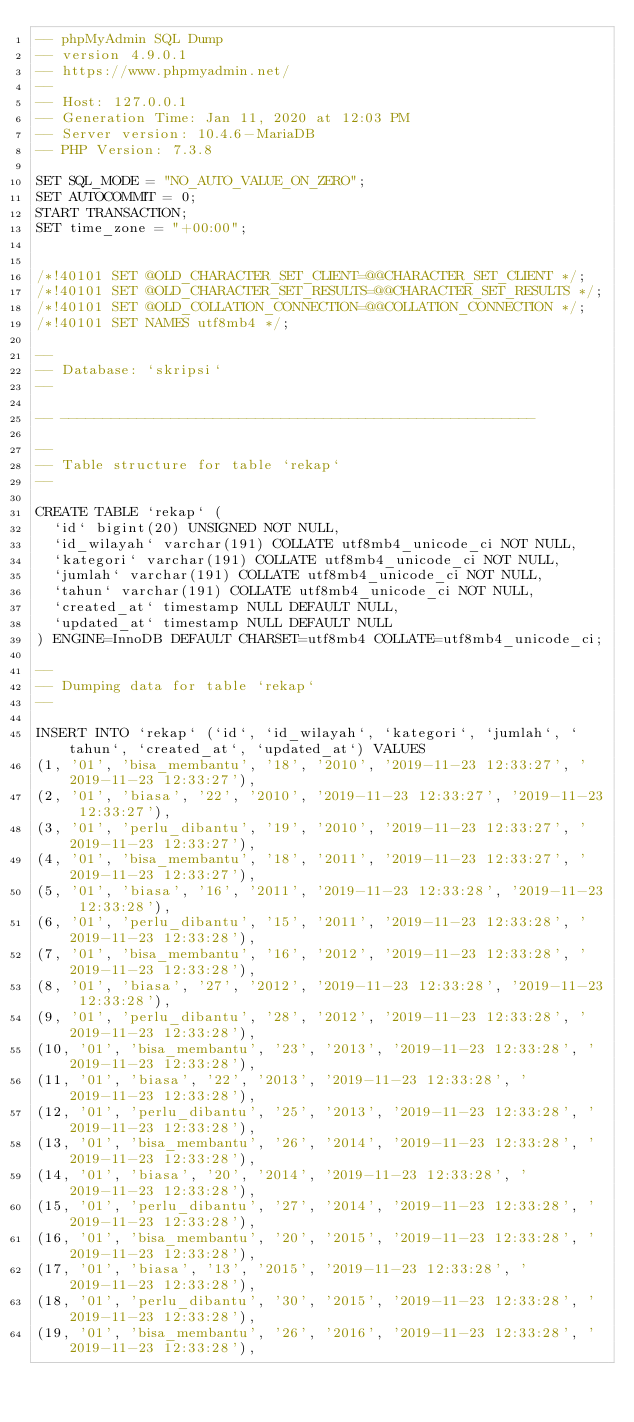Convert code to text. <code><loc_0><loc_0><loc_500><loc_500><_SQL_>-- phpMyAdmin SQL Dump
-- version 4.9.0.1
-- https://www.phpmyadmin.net/
--
-- Host: 127.0.0.1
-- Generation Time: Jan 11, 2020 at 12:03 PM
-- Server version: 10.4.6-MariaDB
-- PHP Version: 7.3.8

SET SQL_MODE = "NO_AUTO_VALUE_ON_ZERO";
SET AUTOCOMMIT = 0;
START TRANSACTION;
SET time_zone = "+00:00";


/*!40101 SET @OLD_CHARACTER_SET_CLIENT=@@CHARACTER_SET_CLIENT */;
/*!40101 SET @OLD_CHARACTER_SET_RESULTS=@@CHARACTER_SET_RESULTS */;
/*!40101 SET @OLD_COLLATION_CONNECTION=@@COLLATION_CONNECTION */;
/*!40101 SET NAMES utf8mb4 */;

--
-- Database: `skripsi`
--

-- --------------------------------------------------------

--
-- Table structure for table `rekap`
--

CREATE TABLE `rekap` (
  `id` bigint(20) UNSIGNED NOT NULL,
  `id_wilayah` varchar(191) COLLATE utf8mb4_unicode_ci NOT NULL,
  `kategori` varchar(191) COLLATE utf8mb4_unicode_ci NOT NULL,
  `jumlah` varchar(191) COLLATE utf8mb4_unicode_ci NOT NULL,
  `tahun` varchar(191) COLLATE utf8mb4_unicode_ci NOT NULL,
  `created_at` timestamp NULL DEFAULT NULL,
  `updated_at` timestamp NULL DEFAULT NULL
) ENGINE=InnoDB DEFAULT CHARSET=utf8mb4 COLLATE=utf8mb4_unicode_ci;

--
-- Dumping data for table `rekap`
--

INSERT INTO `rekap` (`id`, `id_wilayah`, `kategori`, `jumlah`, `tahun`, `created_at`, `updated_at`) VALUES
(1, '01', 'bisa_membantu', '18', '2010', '2019-11-23 12:33:27', '2019-11-23 12:33:27'),
(2, '01', 'biasa', '22', '2010', '2019-11-23 12:33:27', '2019-11-23 12:33:27'),
(3, '01', 'perlu_dibantu', '19', '2010', '2019-11-23 12:33:27', '2019-11-23 12:33:27'),
(4, '01', 'bisa_membantu', '18', '2011', '2019-11-23 12:33:27', '2019-11-23 12:33:27'),
(5, '01', 'biasa', '16', '2011', '2019-11-23 12:33:28', '2019-11-23 12:33:28'),
(6, '01', 'perlu_dibantu', '15', '2011', '2019-11-23 12:33:28', '2019-11-23 12:33:28'),
(7, '01', 'bisa_membantu', '16', '2012', '2019-11-23 12:33:28', '2019-11-23 12:33:28'),
(8, '01', 'biasa', '27', '2012', '2019-11-23 12:33:28', '2019-11-23 12:33:28'),
(9, '01', 'perlu_dibantu', '28', '2012', '2019-11-23 12:33:28', '2019-11-23 12:33:28'),
(10, '01', 'bisa_membantu', '23', '2013', '2019-11-23 12:33:28', '2019-11-23 12:33:28'),
(11, '01', 'biasa', '22', '2013', '2019-11-23 12:33:28', '2019-11-23 12:33:28'),
(12, '01', 'perlu_dibantu', '25', '2013', '2019-11-23 12:33:28', '2019-11-23 12:33:28'),
(13, '01', 'bisa_membantu', '26', '2014', '2019-11-23 12:33:28', '2019-11-23 12:33:28'),
(14, '01', 'biasa', '20', '2014', '2019-11-23 12:33:28', '2019-11-23 12:33:28'),
(15, '01', 'perlu_dibantu', '27', '2014', '2019-11-23 12:33:28', '2019-11-23 12:33:28'),
(16, '01', 'bisa_membantu', '20', '2015', '2019-11-23 12:33:28', '2019-11-23 12:33:28'),
(17, '01', 'biasa', '13', '2015', '2019-11-23 12:33:28', '2019-11-23 12:33:28'),
(18, '01', 'perlu_dibantu', '30', '2015', '2019-11-23 12:33:28', '2019-11-23 12:33:28'),
(19, '01', 'bisa_membantu', '26', '2016', '2019-11-23 12:33:28', '2019-11-23 12:33:28'),</code> 